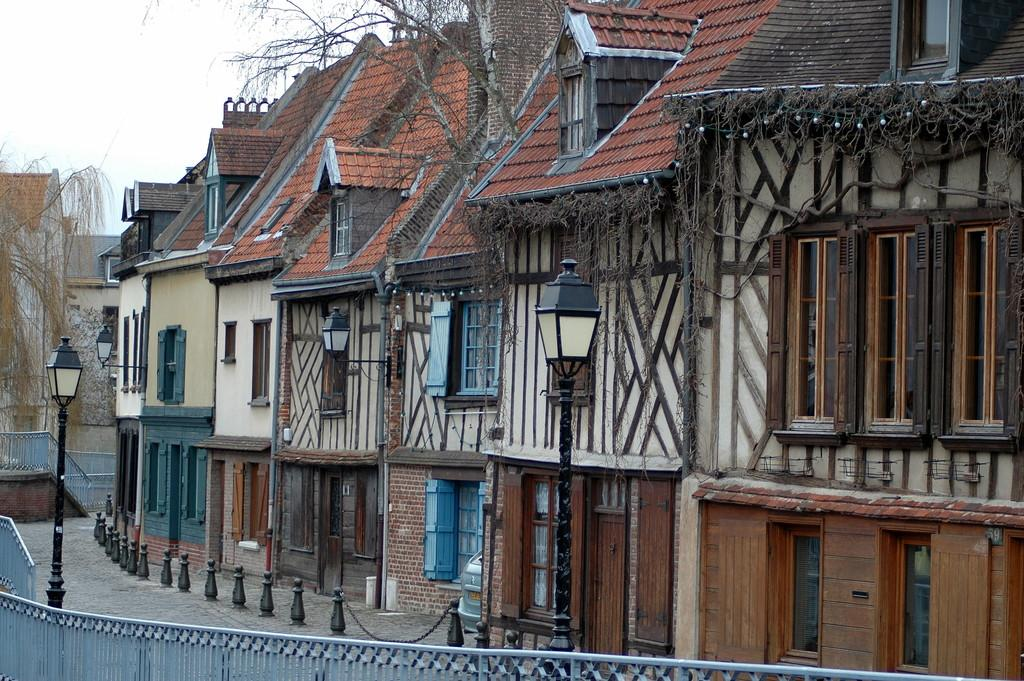What type of structures can be seen in the image? There are buildings in the image. What type of lighting is present in the image? Pole lights are visible in the image. What type of barrier is present in the image? There is a metal grill fence in the image. What can be seen in the sky in the image? Clouds are present in the sky in the image. How many pies are being served at the surprise party in the image? There is no surprise party or pies present in the image. What type of fan is visible in the image? There is no fan present in the image. 